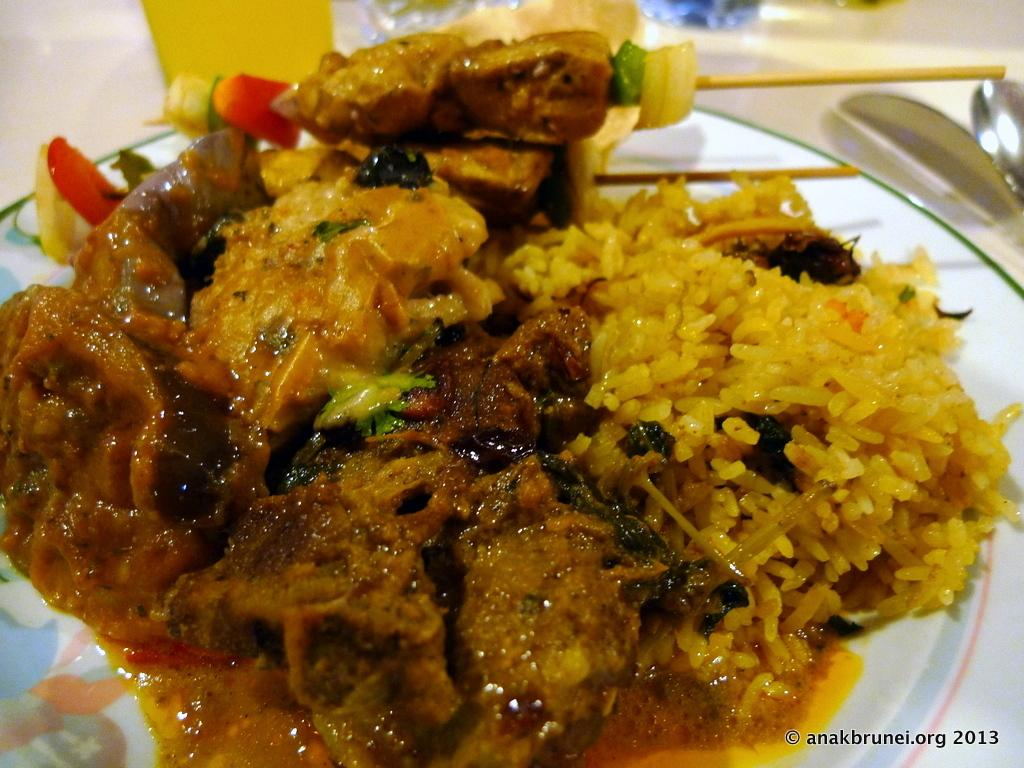What is on the plate in the image? There is food on a plate in the image. Can you see a turkey flying in the image? No, there is no turkey or any flying object present in the image. 